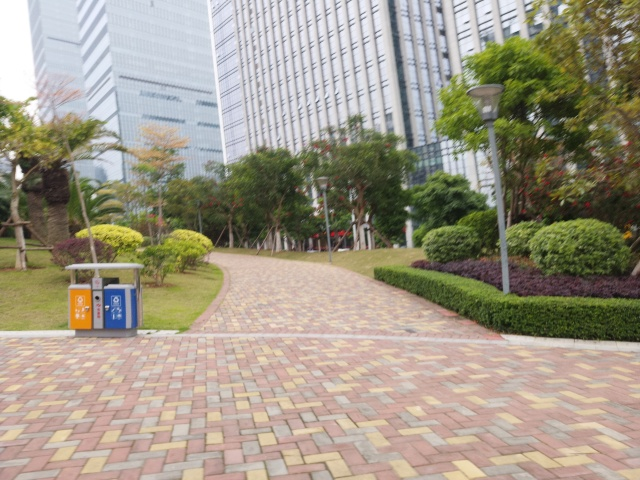Can you describe the architecture of the buildings in the background? The buildings are tall, modern skyscrapers with reflective glass facades commonly seen in urban business districts. Their design appears sleek, emphasizing vertical lines and featuring a dense clustering that is indicative of a bustling city center. 